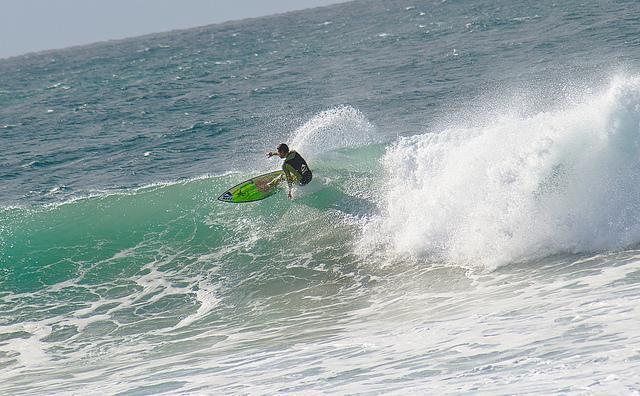How many surfers are in the picture?
Give a very brief answer. 1. How many people are surfing?
Give a very brief answer. 1. How many zebras are there?
Give a very brief answer. 0. 